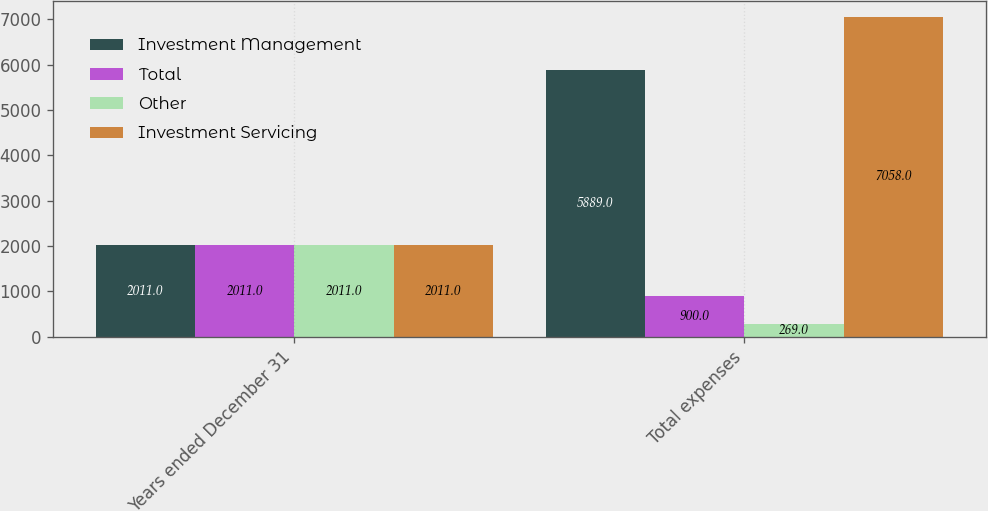Convert chart. <chart><loc_0><loc_0><loc_500><loc_500><stacked_bar_chart><ecel><fcel>Years ended December 31<fcel>Total expenses<nl><fcel>Investment Management<fcel>2011<fcel>5889<nl><fcel>Total<fcel>2011<fcel>900<nl><fcel>Other<fcel>2011<fcel>269<nl><fcel>Investment Servicing<fcel>2011<fcel>7058<nl></chart> 